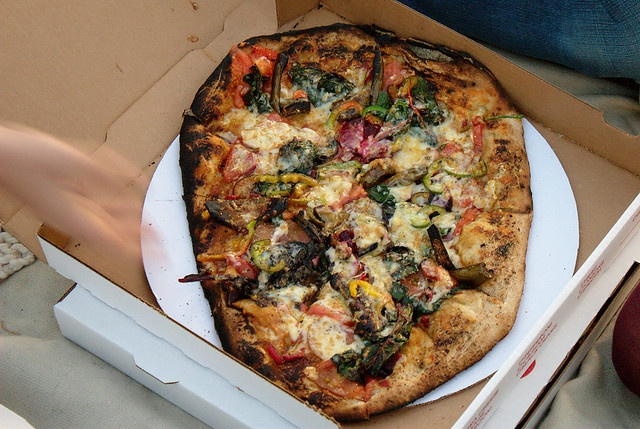Describe the objects in this image and their specific colors. I can see a pizza in gray, black, brown, maroon, and tan tones in this image. 